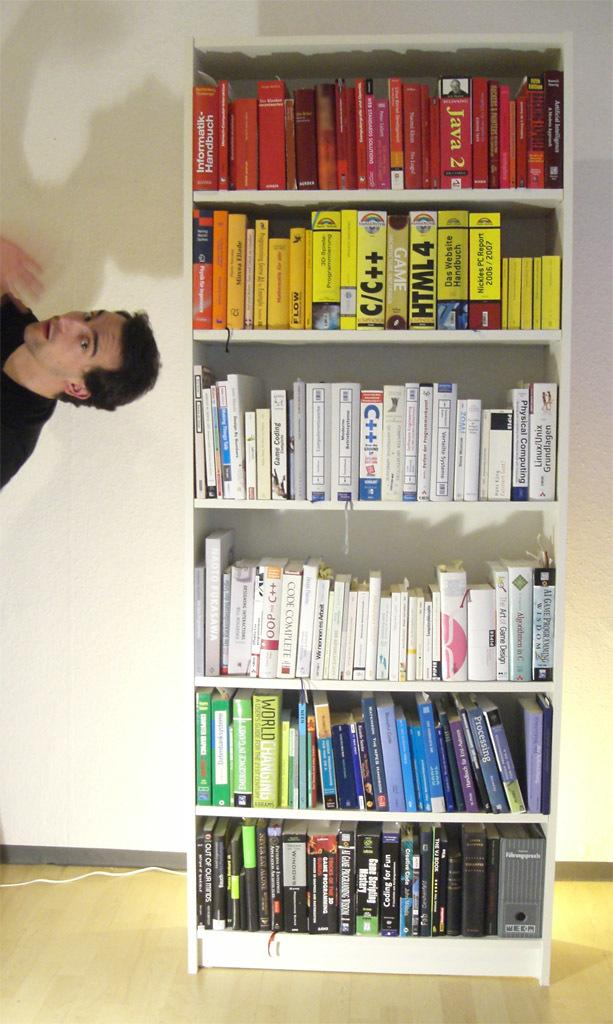<image>
Relay a brief, clear account of the picture shown. A man floats to the side of a bookcase with books like HTML 4. 